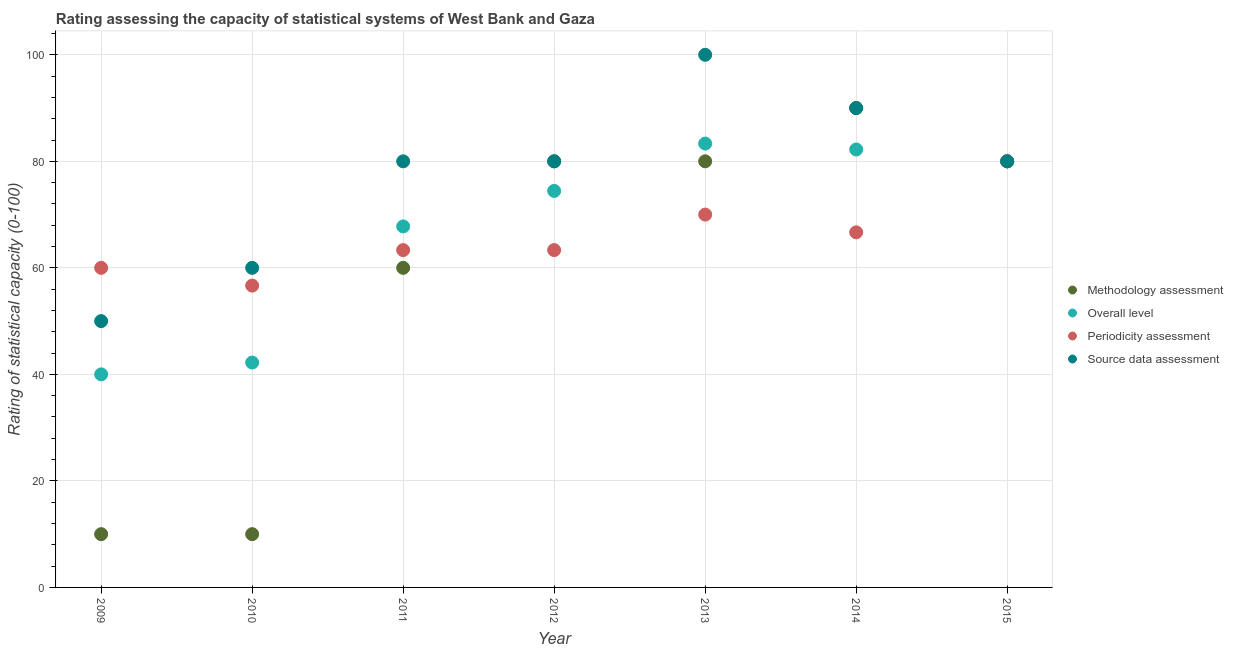How many different coloured dotlines are there?
Provide a short and direct response. 4. What is the source data assessment rating in 2011?
Ensure brevity in your answer.  80. Across all years, what is the maximum periodicity assessment rating?
Provide a short and direct response. 80. Across all years, what is the minimum periodicity assessment rating?
Your answer should be very brief. 56.67. In which year was the source data assessment rating maximum?
Provide a succinct answer. 2013. What is the total methodology assessment rating in the graph?
Make the answer very short. 410. What is the difference between the periodicity assessment rating in 2011 and that in 2015?
Offer a very short reply. -16.67. What is the average periodicity assessment rating per year?
Make the answer very short. 65.71. In the year 2012, what is the difference between the overall level rating and source data assessment rating?
Your answer should be very brief. -5.56. What is the ratio of the overall level rating in 2012 to that in 2013?
Ensure brevity in your answer.  0.89. What is the difference between the highest and the second highest source data assessment rating?
Your answer should be compact. 10. What is the difference between the highest and the lowest methodology assessment rating?
Your answer should be compact. 80. In how many years, is the periodicity assessment rating greater than the average periodicity assessment rating taken over all years?
Your answer should be very brief. 3. Is the sum of the methodology assessment rating in 2011 and 2012 greater than the maximum periodicity assessment rating across all years?
Keep it short and to the point. Yes. Is it the case that in every year, the sum of the periodicity assessment rating and overall level rating is greater than the sum of methodology assessment rating and source data assessment rating?
Your response must be concise. No. Is it the case that in every year, the sum of the methodology assessment rating and overall level rating is greater than the periodicity assessment rating?
Your response must be concise. No. What is the difference between two consecutive major ticks on the Y-axis?
Your response must be concise. 20. Are the values on the major ticks of Y-axis written in scientific E-notation?
Provide a short and direct response. No. Does the graph contain any zero values?
Provide a short and direct response. No. How are the legend labels stacked?
Give a very brief answer. Vertical. What is the title of the graph?
Keep it short and to the point. Rating assessing the capacity of statistical systems of West Bank and Gaza. What is the label or title of the Y-axis?
Offer a terse response. Rating of statistical capacity (0-100). What is the Rating of statistical capacity (0-100) of Methodology assessment in 2009?
Ensure brevity in your answer.  10. What is the Rating of statistical capacity (0-100) in Source data assessment in 2009?
Provide a short and direct response. 50. What is the Rating of statistical capacity (0-100) of Overall level in 2010?
Make the answer very short. 42.22. What is the Rating of statistical capacity (0-100) of Periodicity assessment in 2010?
Your answer should be very brief. 56.67. What is the Rating of statistical capacity (0-100) of Source data assessment in 2010?
Your answer should be compact. 60. What is the Rating of statistical capacity (0-100) of Methodology assessment in 2011?
Offer a terse response. 60. What is the Rating of statistical capacity (0-100) in Overall level in 2011?
Your answer should be very brief. 67.78. What is the Rating of statistical capacity (0-100) in Periodicity assessment in 2011?
Make the answer very short. 63.33. What is the Rating of statistical capacity (0-100) in Overall level in 2012?
Your answer should be compact. 74.44. What is the Rating of statistical capacity (0-100) of Periodicity assessment in 2012?
Provide a succinct answer. 63.33. What is the Rating of statistical capacity (0-100) in Overall level in 2013?
Provide a short and direct response. 83.33. What is the Rating of statistical capacity (0-100) of Overall level in 2014?
Provide a succinct answer. 82.22. What is the Rating of statistical capacity (0-100) of Periodicity assessment in 2014?
Keep it short and to the point. 66.67. What is the Rating of statistical capacity (0-100) of Methodology assessment in 2015?
Your response must be concise. 80. Across all years, what is the maximum Rating of statistical capacity (0-100) in Overall level?
Give a very brief answer. 83.33. Across all years, what is the maximum Rating of statistical capacity (0-100) of Source data assessment?
Your response must be concise. 100. Across all years, what is the minimum Rating of statistical capacity (0-100) in Methodology assessment?
Your response must be concise. 10. Across all years, what is the minimum Rating of statistical capacity (0-100) in Periodicity assessment?
Keep it short and to the point. 56.67. What is the total Rating of statistical capacity (0-100) of Methodology assessment in the graph?
Your answer should be compact. 410. What is the total Rating of statistical capacity (0-100) of Overall level in the graph?
Your response must be concise. 470. What is the total Rating of statistical capacity (0-100) in Periodicity assessment in the graph?
Your answer should be very brief. 460. What is the total Rating of statistical capacity (0-100) in Source data assessment in the graph?
Your response must be concise. 540. What is the difference between the Rating of statistical capacity (0-100) in Methodology assessment in 2009 and that in 2010?
Ensure brevity in your answer.  0. What is the difference between the Rating of statistical capacity (0-100) in Overall level in 2009 and that in 2010?
Make the answer very short. -2.22. What is the difference between the Rating of statistical capacity (0-100) of Methodology assessment in 2009 and that in 2011?
Your response must be concise. -50. What is the difference between the Rating of statistical capacity (0-100) of Overall level in 2009 and that in 2011?
Your answer should be compact. -27.78. What is the difference between the Rating of statistical capacity (0-100) of Methodology assessment in 2009 and that in 2012?
Ensure brevity in your answer.  -70. What is the difference between the Rating of statistical capacity (0-100) of Overall level in 2009 and that in 2012?
Your answer should be very brief. -34.44. What is the difference between the Rating of statistical capacity (0-100) of Methodology assessment in 2009 and that in 2013?
Your answer should be very brief. -70. What is the difference between the Rating of statistical capacity (0-100) in Overall level in 2009 and that in 2013?
Provide a short and direct response. -43.33. What is the difference between the Rating of statistical capacity (0-100) of Periodicity assessment in 2009 and that in 2013?
Ensure brevity in your answer.  -10. What is the difference between the Rating of statistical capacity (0-100) of Methodology assessment in 2009 and that in 2014?
Your response must be concise. -80. What is the difference between the Rating of statistical capacity (0-100) in Overall level in 2009 and that in 2014?
Make the answer very short. -42.22. What is the difference between the Rating of statistical capacity (0-100) of Periodicity assessment in 2009 and that in 2014?
Provide a short and direct response. -6.67. What is the difference between the Rating of statistical capacity (0-100) of Source data assessment in 2009 and that in 2014?
Make the answer very short. -40. What is the difference between the Rating of statistical capacity (0-100) in Methodology assessment in 2009 and that in 2015?
Ensure brevity in your answer.  -70. What is the difference between the Rating of statistical capacity (0-100) of Overall level in 2009 and that in 2015?
Your answer should be very brief. -40. What is the difference between the Rating of statistical capacity (0-100) of Source data assessment in 2009 and that in 2015?
Provide a short and direct response. -30. What is the difference between the Rating of statistical capacity (0-100) of Overall level in 2010 and that in 2011?
Make the answer very short. -25.56. What is the difference between the Rating of statistical capacity (0-100) in Periodicity assessment in 2010 and that in 2011?
Offer a terse response. -6.67. What is the difference between the Rating of statistical capacity (0-100) in Methodology assessment in 2010 and that in 2012?
Give a very brief answer. -70. What is the difference between the Rating of statistical capacity (0-100) of Overall level in 2010 and that in 2012?
Give a very brief answer. -32.22. What is the difference between the Rating of statistical capacity (0-100) of Periodicity assessment in 2010 and that in 2012?
Provide a succinct answer. -6.67. What is the difference between the Rating of statistical capacity (0-100) of Source data assessment in 2010 and that in 2012?
Give a very brief answer. -20. What is the difference between the Rating of statistical capacity (0-100) in Methodology assessment in 2010 and that in 2013?
Your answer should be compact. -70. What is the difference between the Rating of statistical capacity (0-100) of Overall level in 2010 and that in 2013?
Keep it short and to the point. -41.11. What is the difference between the Rating of statistical capacity (0-100) in Periodicity assessment in 2010 and that in 2013?
Keep it short and to the point. -13.33. What is the difference between the Rating of statistical capacity (0-100) in Source data assessment in 2010 and that in 2013?
Give a very brief answer. -40. What is the difference between the Rating of statistical capacity (0-100) in Methodology assessment in 2010 and that in 2014?
Ensure brevity in your answer.  -80. What is the difference between the Rating of statistical capacity (0-100) in Methodology assessment in 2010 and that in 2015?
Provide a short and direct response. -70. What is the difference between the Rating of statistical capacity (0-100) of Overall level in 2010 and that in 2015?
Offer a terse response. -37.78. What is the difference between the Rating of statistical capacity (0-100) in Periodicity assessment in 2010 and that in 2015?
Provide a succinct answer. -23.33. What is the difference between the Rating of statistical capacity (0-100) in Source data assessment in 2010 and that in 2015?
Your answer should be very brief. -20. What is the difference between the Rating of statistical capacity (0-100) in Overall level in 2011 and that in 2012?
Give a very brief answer. -6.67. What is the difference between the Rating of statistical capacity (0-100) of Periodicity assessment in 2011 and that in 2012?
Provide a succinct answer. 0. What is the difference between the Rating of statistical capacity (0-100) of Overall level in 2011 and that in 2013?
Provide a short and direct response. -15.56. What is the difference between the Rating of statistical capacity (0-100) in Periodicity assessment in 2011 and that in 2013?
Make the answer very short. -6.67. What is the difference between the Rating of statistical capacity (0-100) of Source data assessment in 2011 and that in 2013?
Your answer should be compact. -20. What is the difference between the Rating of statistical capacity (0-100) of Overall level in 2011 and that in 2014?
Give a very brief answer. -14.44. What is the difference between the Rating of statistical capacity (0-100) of Periodicity assessment in 2011 and that in 2014?
Make the answer very short. -3.33. What is the difference between the Rating of statistical capacity (0-100) in Source data assessment in 2011 and that in 2014?
Ensure brevity in your answer.  -10. What is the difference between the Rating of statistical capacity (0-100) of Methodology assessment in 2011 and that in 2015?
Keep it short and to the point. -20. What is the difference between the Rating of statistical capacity (0-100) of Overall level in 2011 and that in 2015?
Make the answer very short. -12.22. What is the difference between the Rating of statistical capacity (0-100) in Periodicity assessment in 2011 and that in 2015?
Your answer should be very brief. -16.67. What is the difference between the Rating of statistical capacity (0-100) of Source data assessment in 2011 and that in 2015?
Keep it short and to the point. 0. What is the difference between the Rating of statistical capacity (0-100) in Overall level in 2012 and that in 2013?
Offer a very short reply. -8.89. What is the difference between the Rating of statistical capacity (0-100) of Periodicity assessment in 2012 and that in 2013?
Offer a very short reply. -6.67. What is the difference between the Rating of statistical capacity (0-100) in Methodology assessment in 2012 and that in 2014?
Make the answer very short. -10. What is the difference between the Rating of statistical capacity (0-100) in Overall level in 2012 and that in 2014?
Make the answer very short. -7.78. What is the difference between the Rating of statistical capacity (0-100) in Overall level in 2012 and that in 2015?
Your answer should be very brief. -5.56. What is the difference between the Rating of statistical capacity (0-100) in Periodicity assessment in 2012 and that in 2015?
Provide a short and direct response. -16.67. What is the difference between the Rating of statistical capacity (0-100) in Methodology assessment in 2013 and that in 2014?
Provide a succinct answer. -10. What is the difference between the Rating of statistical capacity (0-100) of Overall level in 2013 and that in 2014?
Your answer should be very brief. 1.11. What is the difference between the Rating of statistical capacity (0-100) of Periodicity assessment in 2013 and that in 2014?
Keep it short and to the point. 3.33. What is the difference between the Rating of statistical capacity (0-100) of Source data assessment in 2013 and that in 2014?
Offer a very short reply. 10. What is the difference between the Rating of statistical capacity (0-100) in Methodology assessment in 2013 and that in 2015?
Offer a very short reply. 0. What is the difference between the Rating of statistical capacity (0-100) in Periodicity assessment in 2013 and that in 2015?
Your answer should be very brief. -10. What is the difference between the Rating of statistical capacity (0-100) of Source data assessment in 2013 and that in 2015?
Provide a short and direct response. 20. What is the difference between the Rating of statistical capacity (0-100) in Overall level in 2014 and that in 2015?
Your response must be concise. 2.22. What is the difference between the Rating of statistical capacity (0-100) in Periodicity assessment in 2014 and that in 2015?
Make the answer very short. -13.33. What is the difference between the Rating of statistical capacity (0-100) in Methodology assessment in 2009 and the Rating of statistical capacity (0-100) in Overall level in 2010?
Your response must be concise. -32.22. What is the difference between the Rating of statistical capacity (0-100) of Methodology assessment in 2009 and the Rating of statistical capacity (0-100) of Periodicity assessment in 2010?
Your answer should be compact. -46.67. What is the difference between the Rating of statistical capacity (0-100) of Methodology assessment in 2009 and the Rating of statistical capacity (0-100) of Source data assessment in 2010?
Keep it short and to the point. -50. What is the difference between the Rating of statistical capacity (0-100) in Overall level in 2009 and the Rating of statistical capacity (0-100) in Periodicity assessment in 2010?
Provide a succinct answer. -16.67. What is the difference between the Rating of statistical capacity (0-100) of Methodology assessment in 2009 and the Rating of statistical capacity (0-100) of Overall level in 2011?
Your response must be concise. -57.78. What is the difference between the Rating of statistical capacity (0-100) in Methodology assessment in 2009 and the Rating of statistical capacity (0-100) in Periodicity assessment in 2011?
Your answer should be very brief. -53.33. What is the difference between the Rating of statistical capacity (0-100) of Methodology assessment in 2009 and the Rating of statistical capacity (0-100) of Source data assessment in 2011?
Offer a very short reply. -70. What is the difference between the Rating of statistical capacity (0-100) in Overall level in 2009 and the Rating of statistical capacity (0-100) in Periodicity assessment in 2011?
Your answer should be very brief. -23.33. What is the difference between the Rating of statistical capacity (0-100) in Overall level in 2009 and the Rating of statistical capacity (0-100) in Source data assessment in 2011?
Your answer should be compact. -40. What is the difference between the Rating of statistical capacity (0-100) in Periodicity assessment in 2009 and the Rating of statistical capacity (0-100) in Source data assessment in 2011?
Give a very brief answer. -20. What is the difference between the Rating of statistical capacity (0-100) in Methodology assessment in 2009 and the Rating of statistical capacity (0-100) in Overall level in 2012?
Give a very brief answer. -64.44. What is the difference between the Rating of statistical capacity (0-100) of Methodology assessment in 2009 and the Rating of statistical capacity (0-100) of Periodicity assessment in 2012?
Your answer should be very brief. -53.33. What is the difference between the Rating of statistical capacity (0-100) in Methodology assessment in 2009 and the Rating of statistical capacity (0-100) in Source data assessment in 2012?
Give a very brief answer. -70. What is the difference between the Rating of statistical capacity (0-100) of Overall level in 2009 and the Rating of statistical capacity (0-100) of Periodicity assessment in 2012?
Keep it short and to the point. -23.33. What is the difference between the Rating of statistical capacity (0-100) in Overall level in 2009 and the Rating of statistical capacity (0-100) in Source data assessment in 2012?
Your answer should be compact. -40. What is the difference between the Rating of statistical capacity (0-100) of Methodology assessment in 2009 and the Rating of statistical capacity (0-100) of Overall level in 2013?
Make the answer very short. -73.33. What is the difference between the Rating of statistical capacity (0-100) in Methodology assessment in 2009 and the Rating of statistical capacity (0-100) in Periodicity assessment in 2013?
Make the answer very short. -60. What is the difference between the Rating of statistical capacity (0-100) in Methodology assessment in 2009 and the Rating of statistical capacity (0-100) in Source data assessment in 2013?
Provide a short and direct response. -90. What is the difference between the Rating of statistical capacity (0-100) in Overall level in 2009 and the Rating of statistical capacity (0-100) in Source data assessment in 2013?
Give a very brief answer. -60. What is the difference between the Rating of statistical capacity (0-100) in Periodicity assessment in 2009 and the Rating of statistical capacity (0-100) in Source data assessment in 2013?
Offer a terse response. -40. What is the difference between the Rating of statistical capacity (0-100) in Methodology assessment in 2009 and the Rating of statistical capacity (0-100) in Overall level in 2014?
Offer a very short reply. -72.22. What is the difference between the Rating of statistical capacity (0-100) in Methodology assessment in 2009 and the Rating of statistical capacity (0-100) in Periodicity assessment in 2014?
Make the answer very short. -56.67. What is the difference between the Rating of statistical capacity (0-100) in Methodology assessment in 2009 and the Rating of statistical capacity (0-100) in Source data assessment in 2014?
Provide a succinct answer. -80. What is the difference between the Rating of statistical capacity (0-100) in Overall level in 2009 and the Rating of statistical capacity (0-100) in Periodicity assessment in 2014?
Offer a terse response. -26.67. What is the difference between the Rating of statistical capacity (0-100) of Overall level in 2009 and the Rating of statistical capacity (0-100) of Source data assessment in 2014?
Provide a short and direct response. -50. What is the difference between the Rating of statistical capacity (0-100) in Methodology assessment in 2009 and the Rating of statistical capacity (0-100) in Overall level in 2015?
Provide a succinct answer. -70. What is the difference between the Rating of statistical capacity (0-100) in Methodology assessment in 2009 and the Rating of statistical capacity (0-100) in Periodicity assessment in 2015?
Your answer should be very brief. -70. What is the difference between the Rating of statistical capacity (0-100) in Methodology assessment in 2009 and the Rating of statistical capacity (0-100) in Source data assessment in 2015?
Keep it short and to the point. -70. What is the difference between the Rating of statistical capacity (0-100) in Overall level in 2009 and the Rating of statistical capacity (0-100) in Periodicity assessment in 2015?
Provide a succinct answer. -40. What is the difference between the Rating of statistical capacity (0-100) of Overall level in 2009 and the Rating of statistical capacity (0-100) of Source data assessment in 2015?
Offer a terse response. -40. What is the difference between the Rating of statistical capacity (0-100) in Periodicity assessment in 2009 and the Rating of statistical capacity (0-100) in Source data assessment in 2015?
Your answer should be very brief. -20. What is the difference between the Rating of statistical capacity (0-100) in Methodology assessment in 2010 and the Rating of statistical capacity (0-100) in Overall level in 2011?
Your answer should be compact. -57.78. What is the difference between the Rating of statistical capacity (0-100) in Methodology assessment in 2010 and the Rating of statistical capacity (0-100) in Periodicity assessment in 2011?
Keep it short and to the point. -53.33. What is the difference between the Rating of statistical capacity (0-100) in Methodology assessment in 2010 and the Rating of statistical capacity (0-100) in Source data assessment in 2011?
Make the answer very short. -70. What is the difference between the Rating of statistical capacity (0-100) in Overall level in 2010 and the Rating of statistical capacity (0-100) in Periodicity assessment in 2011?
Offer a very short reply. -21.11. What is the difference between the Rating of statistical capacity (0-100) in Overall level in 2010 and the Rating of statistical capacity (0-100) in Source data assessment in 2011?
Keep it short and to the point. -37.78. What is the difference between the Rating of statistical capacity (0-100) in Periodicity assessment in 2010 and the Rating of statistical capacity (0-100) in Source data assessment in 2011?
Offer a terse response. -23.33. What is the difference between the Rating of statistical capacity (0-100) of Methodology assessment in 2010 and the Rating of statistical capacity (0-100) of Overall level in 2012?
Your response must be concise. -64.44. What is the difference between the Rating of statistical capacity (0-100) of Methodology assessment in 2010 and the Rating of statistical capacity (0-100) of Periodicity assessment in 2012?
Offer a terse response. -53.33. What is the difference between the Rating of statistical capacity (0-100) in Methodology assessment in 2010 and the Rating of statistical capacity (0-100) in Source data assessment in 2012?
Your answer should be very brief. -70. What is the difference between the Rating of statistical capacity (0-100) in Overall level in 2010 and the Rating of statistical capacity (0-100) in Periodicity assessment in 2012?
Give a very brief answer. -21.11. What is the difference between the Rating of statistical capacity (0-100) in Overall level in 2010 and the Rating of statistical capacity (0-100) in Source data assessment in 2012?
Your answer should be very brief. -37.78. What is the difference between the Rating of statistical capacity (0-100) of Periodicity assessment in 2010 and the Rating of statistical capacity (0-100) of Source data assessment in 2012?
Offer a very short reply. -23.33. What is the difference between the Rating of statistical capacity (0-100) of Methodology assessment in 2010 and the Rating of statistical capacity (0-100) of Overall level in 2013?
Make the answer very short. -73.33. What is the difference between the Rating of statistical capacity (0-100) of Methodology assessment in 2010 and the Rating of statistical capacity (0-100) of Periodicity assessment in 2013?
Provide a succinct answer. -60. What is the difference between the Rating of statistical capacity (0-100) of Methodology assessment in 2010 and the Rating of statistical capacity (0-100) of Source data assessment in 2013?
Provide a succinct answer. -90. What is the difference between the Rating of statistical capacity (0-100) in Overall level in 2010 and the Rating of statistical capacity (0-100) in Periodicity assessment in 2013?
Ensure brevity in your answer.  -27.78. What is the difference between the Rating of statistical capacity (0-100) in Overall level in 2010 and the Rating of statistical capacity (0-100) in Source data assessment in 2013?
Provide a short and direct response. -57.78. What is the difference between the Rating of statistical capacity (0-100) in Periodicity assessment in 2010 and the Rating of statistical capacity (0-100) in Source data assessment in 2013?
Make the answer very short. -43.33. What is the difference between the Rating of statistical capacity (0-100) of Methodology assessment in 2010 and the Rating of statistical capacity (0-100) of Overall level in 2014?
Provide a succinct answer. -72.22. What is the difference between the Rating of statistical capacity (0-100) of Methodology assessment in 2010 and the Rating of statistical capacity (0-100) of Periodicity assessment in 2014?
Ensure brevity in your answer.  -56.67. What is the difference between the Rating of statistical capacity (0-100) in Methodology assessment in 2010 and the Rating of statistical capacity (0-100) in Source data assessment in 2014?
Provide a succinct answer. -80. What is the difference between the Rating of statistical capacity (0-100) of Overall level in 2010 and the Rating of statistical capacity (0-100) of Periodicity assessment in 2014?
Offer a terse response. -24.44. What is the difference between the Rating of statistical capacity (0-100) of Overall level in 2010 and the Rating of statistical capacity (0-100) of Source data assessment in 2014?
Your answer should be very brief. -47.78. What is the difference between the Rating of statistical capacity (0-100) of Periodicity assessment in 2010 and the Rating of statistical capacity (0-100) of Source data assessment in 2014?
Offer a terse response. -33.33. What is the difference between the Rating of statistical capacity (0-100) of Methodology assessment in 2010 and the Rating of statistical capacity (0-100) of Overall level in 2015?
Your answer should be very brief. -70. What is the difference between the Rating of statistical capacity (0-100) of Methodology assessment in 2010 and the Rating of statistical capacity (0-100) of Periodicity assessment in 2015?
Ensure brevity in your answer.  -70. What is the difference between the Rating of statistical capacity (0-100) in Methodology assessment in 2010 and the Rating of statistical capacity (0-100) in Source data assessment in 2015?
Provide a succinct answer. -70. What is the difference between the Rating of statistical capacity (0-100) of Overall level in 2010 and the Rating of statistical capacity (0-100) of Periodicity assessment in 2015?
Keep it short and to the point. -37.78. What is the difference between the Rating of statistical capacity (0-100) of Overall level in 2010 and the Rating of statistical capacity (0-100) of Source data assessment in 2015?
Your response must be concise. -37.78. What is the difference between the Rating of statistical capacity (0-100) of Periodicity assessment in 2010 and the Rating of statistical capacity (0-100) of Source data assessment in 2015?
Offer a terse response. -23.33. What is the difference between the Rating of statistical capacity (0-100) of Methodology assessment in 2011 and the Rating of statistical capacity (0-100) of Overall level in 2012?
Give a very brief answer. -14.44. What is the difference between the Rating of statistical capacity (0-100) in Overall level in 2011 and the Rating of statistical capacity (0-100) in Periodicity assessment in 2012?
Keep it short and to the point. 4.44. What is the difference between the Rating of statistical capacity (0-100) in Overall level in 2011 and the Rating of statistical capacity (0-100) in Source data assessment in 2012?
Give a very brief answer. -12.22. What is the difference between the Rating of statistical capacity (0-100) in Periodicity assessment in 2011 and the Rating of statistical capacity (0-100) in Source data assessment in 2012?
Keep it short and to the point. -16.67. What is the difference between the Rating of statistical capacity (0-100) in Methodology assessment in 2011 and the Rating of statistical capacity (0-100) in Overall level in 2013?
Provide a short and direct response. -23.33. What is the difference between the Rating of statistical capacity (0-100) of Overall level in 2011 and the Rating of statistical capacity (0-100) of Periodicity assessment in 2013?
Your answer should be compact. -2.22. What is the difference between the Rating of statistical capacity (0-100) in Overall level in 2011 and the Rating of statistical capacity (0-100) in Source data assessment in 2013?
Make the answer very short. -32.22. What is the difference between the Rating of statistical capacity (0-100) of Periodicity assessment in 2011 and the Rating of statistical capacity (0-100) of Source data assessment in 2013?
Your answer should be very brief. -36.67. What is the difference between the Rating of statistical capacity (0-100) in Methodology assessment in 2011 and the Rating of statistical capacity (0-100) in Overall level in 2014?
Offer a very short reply. -22.22. What is the difference between the Rating of statistical capacity (0-100) of Methodology assessment in 2011 and the Rating of statistical capacity (0-100) of Periodicity assessment in 2014?
Give a very brief answer. -6.67. What is the difference between the Rating of statistical capacity (0-100) in Methodology assessment in 2011 and the Rating of statistical capacity (0-100) in Source data assessment in 2014?
Give a very brief answer. -30. What is the difference between the Rating of statistical capacity (0-100) in Overall level in 2011 and the Rating of statistical capacity (0-100) in Source data assessment in 2014?
Ensure brevity in your answer.  -22.22. What is the difference between the Rating of statistical capacity (0-100) in Periodicity assessment in 2011 and the Rating of statistical capacity (0-100) in Source data assessment in 2014?
Ensure brevity in your answer.  -26.67. What is the difference between the Rating of statistical capacity (0-100) in Methodology assessment in 2011 and the Rating of statistical capacity (0-100) in Periodicity assessment in 2015?
Make the answer very short. -20. What is the difference between the Rating of statistical capacity (0-100) of Overall level in 2011 and the Rating of statistical capacity (0-100) of Periodicity assessment in 2015?
Keep it short and to the point. -12.22. What is the difference between the Rating of statistical capacity (0-100) of Overall level in 2011 and the Rating of statistical capacity (0-100) of Source data assessment in 2015?
Ensure brevity in your answer.  -12.22. What is the difference between the Rating of statistical capacity (0-100) of Periodicity assessment in 2011 and the Rating of statistical capacity (0-100) of Source data assessment in 2015?
Offer a terse response. -16.67. What is the difference between the Rating of statistical capacity (0-100) of Methodology assessment in 2012 and the Rating of statistical capacity (0-100) of Overall level in 2013?
Ensure brevity in your answer.  -3.33. What is the difference between the Rating of statistical capacity (0-100) of Methodology assessment in 2012 and the Rating of statistical capacity (0-100) of Periodicity assessment in 2013?
Your answer should be very brief. 10. What is the difference between the Rating of statistical capacity (0-100) of Overall level in 2012 and the Rating of statistical capacity (0-100) of Periodicity assessment in 2013?
Your answer should be very brief. 4.44. What is the difference between the Rating of statistical capacity (0-100) of Overall level in 2012 and the Rating of statistical capacity (0-100) of Source data assessment in 2013?
Provide a short and direct response. -25.56. What is the difference between the Rating of statistical capacity (0-100) of Periodicity assessment in 2012 and the Rating of statistical capacity (0-100) of Source data assessment in 2013?
Give a very brief answer. -36.67. What is the difference between the Rating of statistical capacity (0-100) of Methodology assessment in 2012 and the Rating of statistical capacity (0-100) of Overall level in 2014?
Your response must be concise. -2.22. What is the difference between the Rating of statistical capacity (0-100) in Methodology assessment in 2012 and the Rating of statistical capacity (0-100) in Periodicity assessment in 2014?
Provide a short and direct response. 13.33. What is the difference between the Rating of statistical capacity (0-100) in Overall level in 2012 and the Rating of statistical capacity (0-100) in Periodicity assessment in 2014?
Provide a succinct answer. 7.78. What is the difference between the Rating of statistical capacity (0-100) in Overall level in 2012 and the Rating of statistical capacity (0-100) in Source data assessment in 2014?
Make the answer very short. -15.56. What is the difference between the Rating of statistical capacity (0-100) of Periodicity assessment in 2012 and the Rating of statistical capacity (0-100) of Source data assessment in 2014?
Provide a succinct answer. -26.67. What is the difference between the Rating of statistical capacity (0-100) in Methodology assessment in 2012 and the Rating of statistical capacity (0-100) in Source data assessment in 2015?
Your answer should be compact. 0. What is the difference between the Rating of statistical capacity (0-100) of Overall level in 2012 and the Rating of statistical capacity (0-100) of Periodicity assessment in 2015?
Keep it short and to the point. -5.56. What is the difference between the Rating of statistical capacity (0-100) of Overall level in 2012 and the Rating of statistical capacity (0-100) of Source data assessment in 2015?
Keep it short and to the point. -5.56. What is the difference between the Rating of statistical capacity (0-100) in Periodicity assessment in 2012 and the Rating of statistical capacity (0-100) in Source data assessment in 2015?
Provide a succinct answer. -16.67. What is the difference between the Rating of statistical capacity (0-100) in Methodology assessment in 2013 and the Rating of statistical capacity (0-100) in Overall level in 2014?
Provide a short and direct response. -2.22. What is the difference between the Rating of statistical capacity (0-100) of Methodology assessment in 2013 and the Rating of statistical capacity (0-100) of Periodicity assessment in 2014?
Keep it short and to the point. 13.33. What is the difference between the Rating of statistical capacity (0-100) of Overall level in 2013 and the Rating of statistical capacity (0-100) of Periodicity assessment in 2014?
Make the answer very short. 16.67. What is the difference between the Rating of statistical capacity (0-100) of Overall level in 2013 and the Rating of statistical capacity (0-100) of Source data assessment in 2014?
Provide a short and direct response. -6.67. What is the difference between the Rating of statistical capacity (0-100) of Methodology assessment in 2013 and the Rating of statistical capacity (0-100) of Overall level in 2015?
Your answer should be very brief. 0. What is the difference between the Rating of statistical capacity (0-100) in Methodology assessment in 2013 and the Rating of statistical capacity (0-100) in Periodicity assessment in 2015?
Make the answer very short. 0. What is the difference between the Rating of statistical capacity (0-100) of Overall level in 2013 and the Rating of statistical capacity (0-100) of Periodicity assessment in 2015?
Keep it short and to the point. 3.33. What is the difference between the Rating of statistical capacity (0-100) in Methodology assessment in 2014 and the Rating of statistical capacity (0-100) in Overall level in 2015?
Provide a succinct answer. 10. What is the difference between the Rating of statistical capacity (0-100) in Methodology assessment in 2014 and the Rating of statistical capacity (0-100) in Source data assessment in 2015?
Make the answer very short. 10. What is the difference between the Rating of statistical capacity (0-100) in Overall level in 2014 and the Rating of statistical capacity (0-100) in Periodicity assessment in 2015?
Provide a short and direct response. 2.22. What is the difference between the Rating of statistical capacity (0-100) of Overall level in 2014 and the Rating of statistical capacity (0-100) of Source data assessment in 2015?
Keep it short and to the point. 2.22. What is the difference between the Rating of statistical capacity (0-100) in Periodicity assessment in 2014 and the Rating of statistical capacity (0-100) in Source data assessment in 2015?
Provide a succinct answer. -13.33. What is the average Rating of statistical capacity (0-100) of Methodology assessment per year?
Give a very brief answer. 58.57. What is the average Rating of statistical capacity (0-100) of Overall level per year?
Keep it short and to the point. 67.14. What is the average Rating of statistical capacity (0-100) of Periodicity assessment per year?
Make the answer very short. 65.71. What is the average Rating of statistical capacity (0-100) in Source data assessment per year?
Keep it short and to the point. 77.14. In the year 2009, what is the difference between the Rating of statistical capacity (0-100) in Methodology assessment and Rating of statistical capacity (0-100) in Overall level?
Your response must be concise. -30. In the year 2009, what is the difference between the Rating of statistical capacity (0-100) of Methodology assessment and Rating of statistical capacity (0-100) of Periodicity assessment?
Your answer should be very brief. -50. In the year 2009, what is the difference between the Rating of statistical capacity (0-100) in Overall level and Rating of statistical capacity (0-100) in Source data assessment?
Give a very brief answer. -10. In the year 2009, what is the difference between the Rating of statistical capacity (0-100) of Periodicity assessment and Rating of statistical capacity (0-100) of Source data assessment?
Provide a short and direct response. 10. In the year 2010, what is the difference between the Rating of statistical capacity (0-100) in Methodology assessment and Rating of statistical capacity (0-100) in Overall level?
Provide a short and direct response. -32.22. In the year 2010, what is the difference between the Rating of statistical capacity (0-100) in Methodology assessment and Rating of statistical capacity (0-100) in Periodicity assessment?
Offer a terse response. -46.67. In the year 2010, what is the difference between the Rating of statistical capacity (0-100) in Overall level and Rating of statistical capacity (0-100) in Periodicity assessment?
Your response must be concise. -14.44. In the year 2010, what is the difference between the Rating of statistical capacity (0-100) in Overall level and Rating of statistical capacity (0-100) in Source data assessment?
Keep it short and to the point. -17.78. In the year 2010, what is the difference between the Rating of statistical capacity (0-100) of Periodicity assessment and Rating of statistical capacity (0-100) of Source data assessment?
Offer a very short reply. -3.33. In the year 2011, what is the difference between the Rating of statistical capacity (0-100) of Methodology assessment and Rating of statistical capacity (0-100) of Overall level?
Your response must be concise. -7.78. In the year 2011, what is the difference between the Rating of statistical capacity (0-100) of Methodology assessment and Rating of statistical capacity (0-100) of Source data assessment?
Provide a succinct answer. -20. In the year 2011, what is the difference between the Rating of statistical capacity (0-100) of Overall level and Rating of statistical capacity (0-100) of Periodicity assessment?
Provide a short and direct response. 4.44. In the year 2011, what is the difference between the Rating of statistical capacity (0-100) in Overall level and Rating of statistical capacity (0-100) in Source data assessment?
Make the answer very short. -12.22. In the year 2011, what is the difference between the Rating of statistical capacity (0-100) of Periodicity assessment and Rating of statistical capacity (0-100) of Source data assessment?
Ensure brevity in your answer.  -16.67. In the year 2012, what is the difference between the Rating of statistical capacity (0-100) in Methodology assessment and Rating of statistical capacity (0-100) in Overall level?
Your answer should be very brief. 5.56. In the year 2012, what is the difference between the Rating of statistical capacity (0-100) in Methodology assessment and Rating of statistical capacity (0-100) in Periodicity assessment?
Give a very brief answer. 16.67. In the year 2012, what is the difference between the Rating of statistical capacity (0-100) in Methodology assessment and Rating of statistical capacity (0-100) in Source data assessment?
Ensure brevity in your answer.  0. In the year 2012, what is the difference between the Rating of statistical capacity (0-100) of Overall level and Rating of statistical capacity (0-100) of Periodicity assessment?
Give a very brief answer. 11.11. In the year 2012, what is the difference between the Rating of statistical capacity (0-100) in Overall level and Rating of statistical capacity (0-100) in Source data assessment?
Your answer should be very brief. -5.56. In the year 2012, what is the difference between the Rating of statistical capacity (0-100) in Periodicity assessment and Rating of statistical capacity (0-100) in Source data assessment?
Your answer should be very brief. -16.67. In the year 2013, what is the difference between the Rating of statistical capacity (0-100) in Methodology assessment and Rating of statistical capacity (0-100) in Periodicity assessment?
Give a very brief answer. 10. In the year 2013, what is the difference between the Rating of statistical capacity (0-100) of Methodology assessment and Rating of statistical capacity (0-100) of Source data assessment?
Provide a succinct answer. -20. In the year 2013, what is the difference between the Rating of statistical capacity (0-100) of Overall level and Rating of statistical capacity (0-100) of Periodicity assessment?
Ensure brevity in your answer.  13.33. In the year 2013, what is the difference between the Rating of statistical capacity (0-100) in Overall level and Rating of statistical capacity (0-100) in Source data assessment?
Keep it short and to the point. -16.67. In the year 2013, what is the difference between the Rating of statistical capacity (0-100) in Periodicity assessment and Rating of statistical capacity (0-100) in Source data assessment?
Your answer should be compact. -30. In the year 2014, what is the difference between the Rating of statistical capacity (0-100) of Methodology assessment and Rating of statistical capacity (0-100) of Overall level?
Ensure brevity in your answer.  7.78. In the year 2014, what is the difference between the Rating of statistical capacity (0-100) of Methodology assessment and Rating of statistical capacity (0-100) of Periodicity assessment?
Your response must be concise. 23.33. In the year 2014, what is the difference between the Rating of statistical capacity (0-100) in Methodology assessment and Rating of statistical capacity (0-100) in Source data assessment?
Your answer should be compact. 0. In the year 2014, what is the difference between the Rating of statistical capacity (0-100) of Overall level and Rating of statistical capacity (0-100) of Periodicity assessment?
Offer a terse response. 15.56. In the year 2014, what is the difference between the Rating of statistical capacity (0-100) in Overall level and Rating of statistical capacity (0-100) in Source data assessment?
Your response must be concise. -7.78. In the year 2014, what is the difference between the Rating of statistical capacity (0-100) of Periodicity assessment and Rating of statistical capacity (0-100) of Source data assessment?
Provide a succinct answer. -23.33. In the year 2015, what is the difference between the Rating of statistical capacity (0-100) of Methodology assessment and Rating of statistical capacity (0-100) of Periodicity assessment?
Offer a very short reply. 0. In the year 2015, what is the difference between the Rating of statistical capacity (0-100) in Overall level and Rating of statistical capacity (0-100) in Source data assessment?
Give a very brief answer. 0. What is the ratio of the Rating of statistical capacity (0-100) of Periodicity assessment in 2009 to that in 2010?
Your response must be concise. 1.06. What is the ratio of the Rating of statistical capacity (0-100) in Source data assessment in 2009 to that in 2010?
Ensure brevity in your answer.  0.83. What is the ratio of the Rating of statistical capacity (0-100) in Methodology assessment in 2009 to that in 2011?
Your answer should be compact. 0.17. What is the ratio of the Rating of statistical capacity (0-100) in Overall level in 2009 to that in 2011?
Provide a short and direct response. 0.59. What is the ratio of the Rating of statistical capacity (0-100) of Overall level in 2009 to that in 2012?
Give a very brief answer. 0.54. What is the ratio of the Rating of statistical capacity (0-100) in Source data assessment in 2009 to that in 2012?
Offer a terse response. 0.62. What is the ratio of the Rating of statistical capacity (0-100) in Methodology assessment in 2009 to that in 2013?
Offer a terse response. 0.12. What is the ratio of the Rating of statistical capacity (0-100) of Overall level in 2009 to that in 2013?
Your response must be concise. 0.48. What is the ratio of the Rating of statistical capacity (0-100) of Periodicity assessment in 2009 to that in 2013?
Your answer should be compact. 0.86. What is the ratio of the Rating of statistical capacity (0-100) in Source data assessment in 2009 to that in 2013?
Make the answer very short. 0.5. What is the ratio of the Rating of statistical capacity (0-100) in Overall level in 2009 to that in 2014?
Make the answer very short. 0.49. What is the ratio of the Rating of statistical capacity (0-100) of Periodicity assessment in 2009 to that in 2014?
Your answer should be compact. 0.9. What is the ratio of the Rating of statistical capacity (0-100) in Source data assessment in 2009 to that in 2014?
Keep it short and to the point. 0.56. What is the ratio of the Rating of statistical capacity (0-100) in Methodology assessment in 2009 to that in 2015?
Provide a short and direct response. 0.12. What is the ratio of the Rating of statistical capacity (0-100) of Source data assessment in 2009 to that in 2015?
Your answer should be compact. 0.62. What is the ratio of the Rating of statistical capacity (0-100) of Methodology assessment in 2010 to that in 2011?
Your answer should be compact. 0.17. What is the ratio of the Rating of statistical capacity (0-100) of Overall level in 2010 to that in 2011?
Offer a terse response. 0.62. What is the ratio of the Rating of statistical capacity (0-100) in Periodicity assessment in 2010 to that in 2011?
Your answer should be very brief. 0.89. What is the ratio of the Rating of statistical capacity (0-100) in Source data assessment in 2010 to that in 2011?
Your answer should be compact. 0.75. What is the ratio of the Rating of statistical capacity (0-100) of Overall level in 2010 to that in 2012?
Ensure brevity in your answer.  0.57. What is the ratio of the Rating of statistical capacity (0-100) of Periodicity assessment in 2010 to that in 2012?
Offer a terse response. 0.89. What is the ratio of the Rating of statistical capacity (0-100) in Source data assessment in 2010 to that in 2012?
Provide a succinct answer. 0.75. What is the ratio of the Rating of statistical capacity (0-100) in Methodology assessment in 2010 to that in 2013?
Give a very brief answer. 0.12. What is the ratio of the Rating of statistical capacity (0-100) in Overall level in 2010 to that in 2013?
Make the answer very short. 0.51. What is the ratio of the Rating of statistical capacity (0-100) in Periodicity assessment in 2010 to that in 2013?
Your answer should be compact. 0.81. What is the ratio of the Rating of statistical capacity (0-100) in Source data assessment in 2010 to that in 2013?
Offer a terse response. 0.6. What is the ratio of the Rating of statistical capacity (0-100) in Methodology assessment in 2010 to that in 2014?
Ensure brevity in your answer.  0.11. What is the ratio of the Rating of statistical capacity (0-100) in Overall level in 2010 to that in 2014?
Make the answer very short. 0.51. What is the ratio of the Rating of statistical capacity (0-100) of Periodicity assessment in 2010 to that in 2014?
Make the answer very short. 0.85. What is the ratio of the Rating of statistical capacity (0-100) of Overall level in 2010 to that in 2015?
Provide a succinct answer. 0.53. What is the ratio of the Rating of statistical capacity (0-100) of Periodicity assessment in 2010 to that in 2015?
Ensure brevity in your answer.  0.71. What is the ratio of the Rating of statistical capacity (0-100) in Overall level in 2011 to that in 2012?
Provide a succinct answer. 0.91. What is the ratio of the Rating of statistical capacity (0-100) of Source data assessment in 2011 to that in 2012?
Your answer should be very brief. 1. What is the ratio of the Rating of statistical capacity (0-100) in Methodology assessment in 2011 to that in 2013?
Your response must be concise. 0.75. What is the ratio of the Rating of statistical capacity (0-100) of Overall level in 2011 to that in 2013?
Make the answer very short. 0.81. What is the ratio of the Rating of statistical capacity (0-100) in Periodicity assessment in 2011 to that in 2013?
Offer a very short reply. 0.9. What is the ratio of the Rating of statistical capacity (0-100) of Source data assessment in 2011 to that in 2013?
Make the answer very short. 0.8. What is the ratio of the Rating of statistical capacity (0-100) of Overall level in 2011 to that in 2014?
Your answer should be compact. 0.82. What is the ratio of the Rating of statistical capacity (0-100) in Periodicity assessment in 2011 to that in 2014?
Offer a terse response. 0.95. What is the ratio of the Rating of statistical capacity (0-100) in Source data assessment in 2011 to that in 2014?
Keep it short and to the point. 0.89. What is the ratio of the Rating of statistical capacity (0-100) in Methodology assessment in 2011 to that in 2015?
Keep it short and to the point. 0.75. What is the ratio of the Rating of statistical capacity (0-100) of Overall level in 2011 to that in 2015?
Offer a very short reply. 0.85. What is the ratio of the Rating of statistical capacity (0-100) in Periodicity assessment in 2011 to that in 2015?
Offer a very short reply. 0.79. What is the ratio of the Rating of statistical capacity (0-100) of Methodology assessment in 2012 to that in 2013?
Keep it short and to the point. 1. What is the ratio of the Rating of statistical capacity (0-100) in Overall level in 2012 to that in 2013?
Give a very brief answer. 0.89. What is the ratio of the Rating of statistical capacity (0-100) of Periodicity assessment in 2012 to that in 2013?
Give a very brief answer. 0.9. What is the ratio of the Rating of statistical capacity (0-100) of Methodology assessment in 2012 to that in 2014?
Give a very brief answer. 0.89. What is the ratio of the Rating of statistical capacity (0-100) of Overall level in 2012 to that in 2014?
Your answer should be very brief. 0.91. What is the ratio of the Rating of statistical capacity (0-100) in Periodicity assessment in 2012 to that in 2014?
Offer a very short reply. 0.95. What is the ratio of the Rating of statistical capacity (0-100) in Source data assessment in 2012 to that in 2014?
Provide a succinct answer. 0.89. What is the ratio of the Rating of statistical capacity (0-100) in Overall level in 2012 to that in 2015?
Provide a short and direct response. 0.93. What is the ratio of the Rating of statistical capacity (0-100) of Periodicity assessment in 2012 to that in 2015?
Ensure brevity in your answer.  0.79. What is the ratio of the Rating of statistical capacity (0-100) of Source data assessment in 2012 to that in 2015?
Give a very brief answer. 1. What is the ratio of the Rating of statistical capacity (0-100) of Overall level in 2013 to that in 2014?
Give a very brief answer. 1.01. What is the ratio of the Rating of statistical capacity (0-100) of Methodology assessment in 2013 to that in 2015?
Your answer should be very brief. 1. What is the ratio of the Rating of statistical capacity (0-100) of Overall level in 2013 to that in 2015?
Your answer should be very brief. 1.04. What is the ratio of the Rating of statistical capacity (0-100) of Source data assessment in 2013 to that in 2015?
Give a very brief answer. 1.25. What is the ratio of the Rating of statistical capacity (0-100) in Overall level in 2014 to that in 2015?
Offer a very short reply. 1.03. What is the ratio of the Rating of statistical capacity (0-100) of Source data assessment in 2014 to that in 2015?
Keep it short and to the point. 1.12. What is the difference between the highest and the second highest Rating of statistical capacity (0-100) in Periodicity assessment?
Provide a short and direct response. 10. What is the difference between the highest and the lowest Rating of statistical capacity (0-100) of Methodology assessment?
Provide a succinct answer. 80. What is the difference between the highest and the lowest Rating of statistical capacity (0-100) of Overall level?
Make the answer very short. 43.33. What is the difference between the highest and the lowest Rating of statistical capacity (0-100) in Periodicity assessment?
Ensure brevity in your answer.  23.33. What is the difference between the highest and the lowest Rating of statistical capacity (0-100) of Source data assessment?
Offer a terse response. 50. 